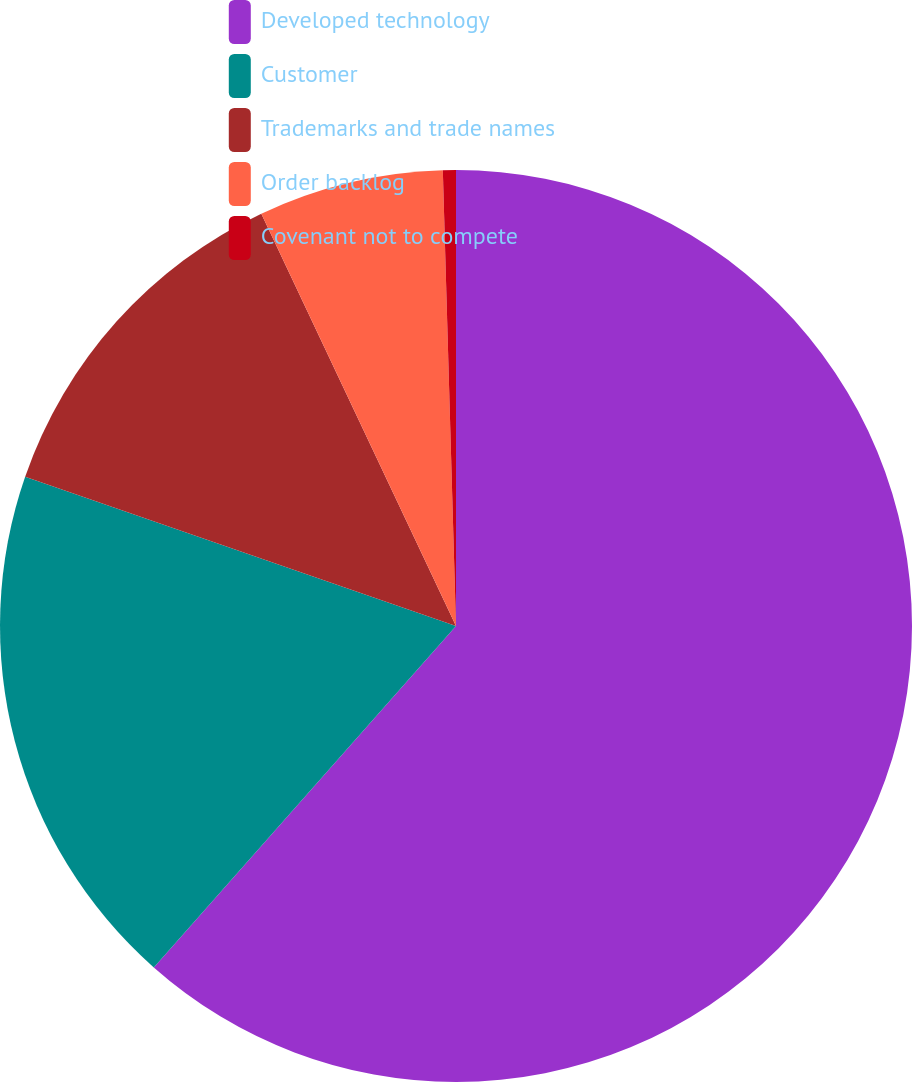Convert chart to OTSL. <chart><loc_0><loc_0><loc_500><loc_500><pie_chart><fcel>Developed technology<fcel>Customer<fcel>Trademarks and trade names<fcel>Order backlog<fcel>Covenant not to compete<nl><fcel>61.53%<fcel>18.78%<fcel>12.67%<fcel>6.56%<fcel>0.46%<nl></chart> 